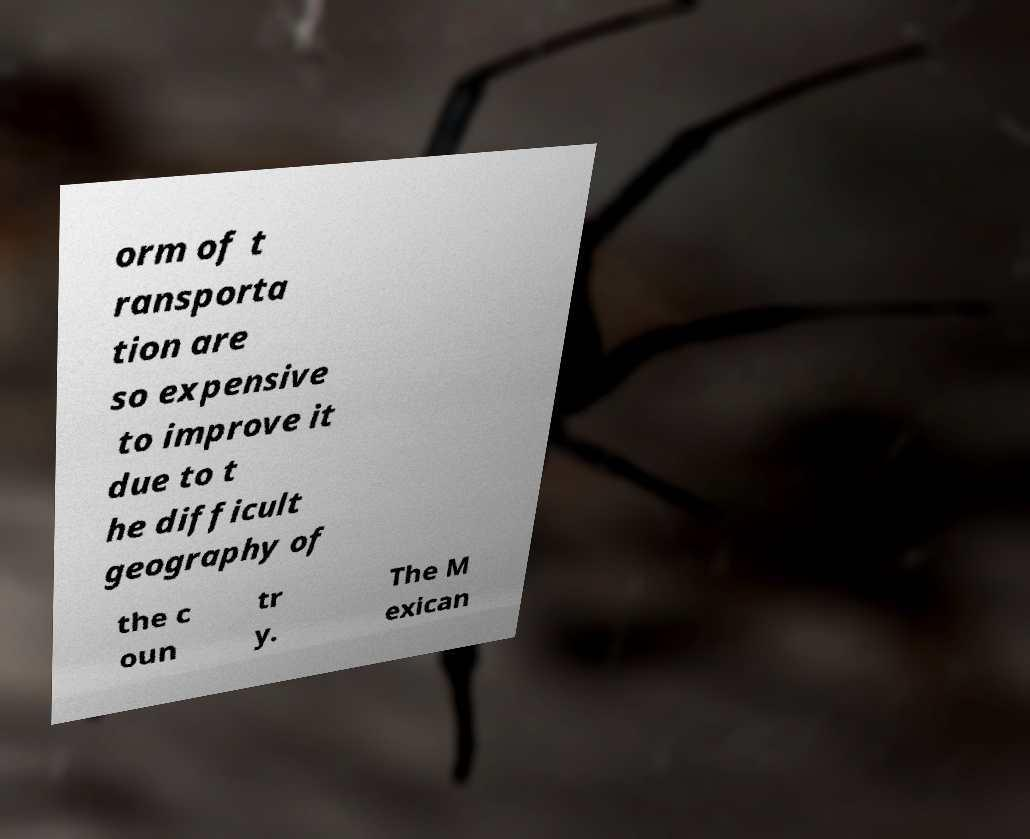For documentation purposes, I need the text within this image transcribed. Could you provide that? orm of t ransporta tion are so expensive to improve it due to t he difficult geography of the c oun tr y. The M exican 